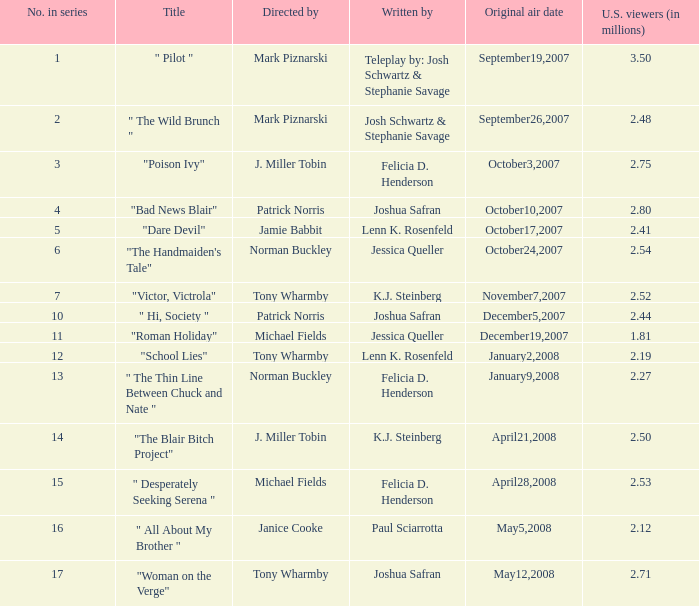How many directed by have 2.80 as u.s. viewers  (in millions)? 1.0. 